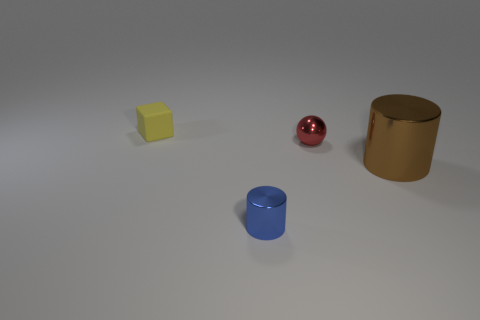What is the size of the shiny cylinder to the right of the small metal object that is on the right side of the small blue shiny cylinder in front of the red metal thing?
Keep it short and to the point. Large. What number of other objects are there of the same material as the brown thing?
Your answer should be very brief. 2. What is the color of the shiny cylinder that is in front of the brown object?
Offer a very short reply. Blue. There is a tiny object behind the metallic thing that is behind the cylinder that is behind the tiny blue thing; what is its material?
Offer a terse response. Rubber. Are there any other brown objects that have the same shape as the brown shiny thing?
Your answer should be very brief. No. There is a red metal thing that is the same size as the yellow object; what is its shape?
Your answer should be very brief. Sphere. How many objects are both in front of the ball and left of the tiny ball?
Your response must be concise. 1. Is the number of small red shiny objects that are in front of the small blue object less than the number of small yellow cubes?
Offer a terse response. Yes. Are there any red metal cylinders that have the same size as the brown metallic cylinder?
Give a very brief answer. No. The tiny cylinder that is the same material as the big cylinder is what color?
Provide a short and direct response. Blue. 